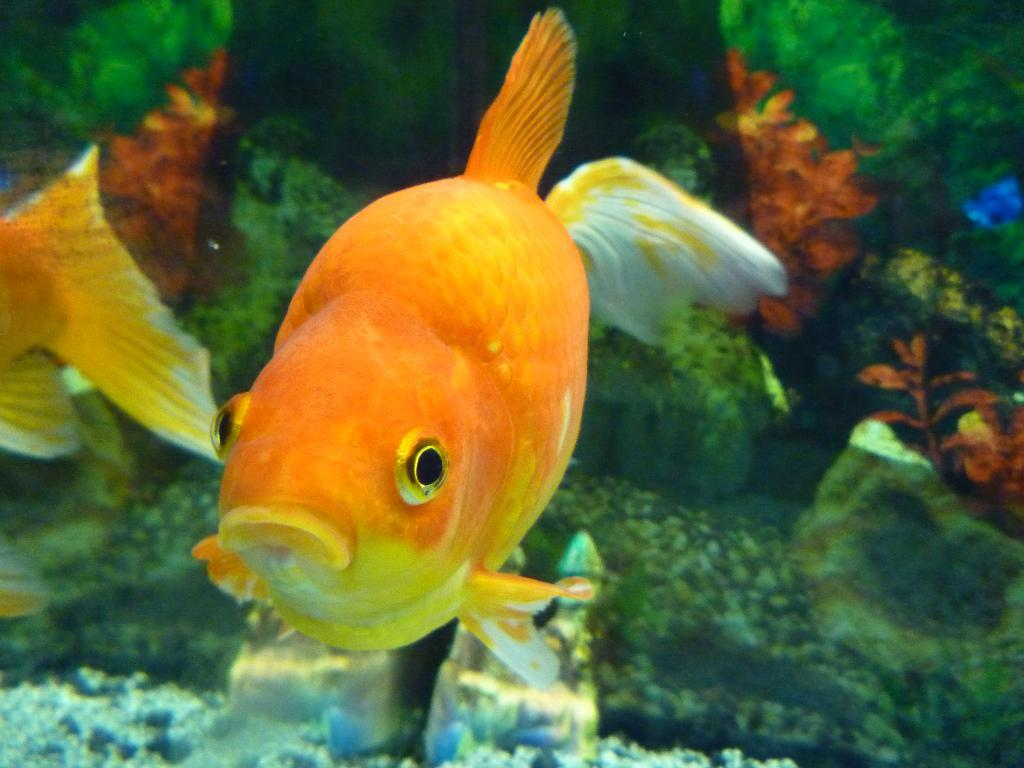What is the main subject of the image? There is a fish in the image. Where is the fish located in the image? The fish is in the center of the image. What is the environment surrounding the fish? The fish is in the water. What type of smell can be detected from the fish in the image? There is no information about the smell of the fish in the image, and therefore it cannot be determined. 